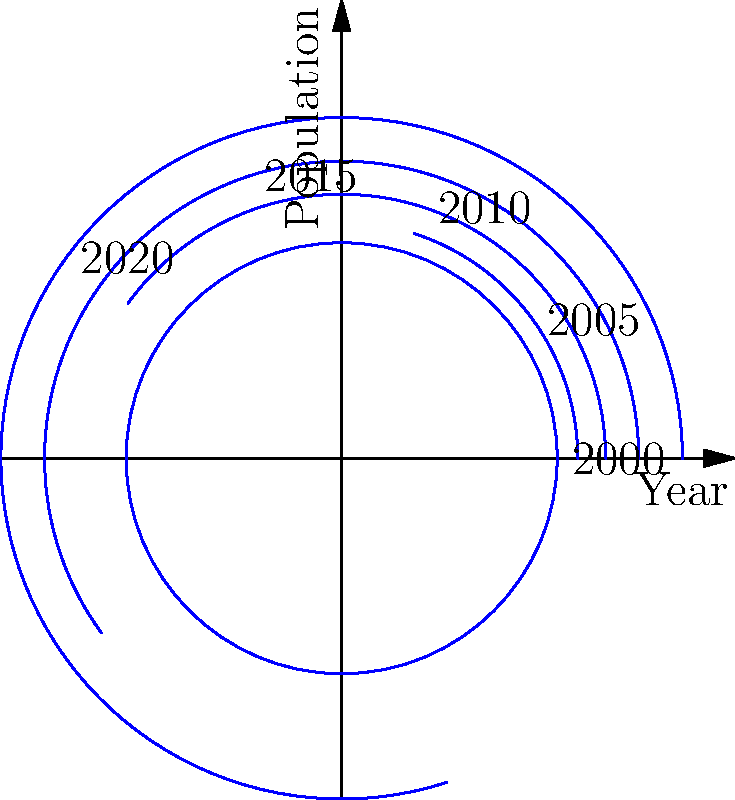Based on the polar area diagram showing the growth of your hometown over time, in which period did the town experience the most rapid population growth? To determine the period of most rapid population growth, we need to analyze the increase in area between consecutive time periods. The area of each sector represents the population at that time.

1. Calculate the area for each time period:
   - 2000: $A_1 = \pi r_1^2 = \pi (100000 * scale)$
   - 2005: $A_2 = \pi r_2^2 = \pi (120000 * scale)$
   - 2010: $A_3 = \pi r_3^2 = \pi (150000 * scale)$
   - 2015: $A_4 = \pi r_4^2 = \pi (190000 * scale)$
   - 2020: $A_5 = \pi r_5^2 = \pi (250000 * scale)$

2. Calculate the difference in area between consecutive periods:
   - 2000-2005: $\Delta A_1 = A_2 - A_1$
   - 2005-2010: $\Delta A_2 = A_3 - A_2$
   - 2010-2015: $\Delta A_3 = A_4 - A_3$
   - 2015-2020: $\Delta A_4 = A_5 - A_4$

3. Compare the differences:
   $\Delta A_4 > \Delta A_3 > \Delta A_2 > \Delta A_1$

4. The largest difference in area is between 2015 and 2020, indicating the most rapid growth in this period.
Answer: 2015-2020 